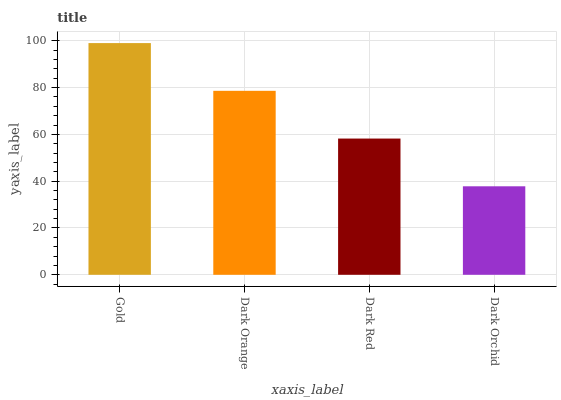Is Dark Orchid the minimum?
Answer yes or no. Yes. Is Gold the maximum?
Answer yes or no. Yes. Is Dark Orange the minimum?
Answer yes or no. No. Is Dark Orange the maximum?
Answer yes or no. No. Is Gold greater than Dark Orange?
Answer yes or no. Yes. Is Dark Orange less than Gold?
Answer yes or no. Yes. Is Dark Orange greater than Gold?
Answer yes or no. No. Is Gold less than Dark Orange?
Answer yes or no. No. Is Dark Orange the high median?
Answer yes or no. Yes. Is Dark Red the low median?
Answer yes or no. Yes. Is Gold the high median?
Answer yes or no. No. Is Dark Orange the low median?
Answer yes or no. No. 